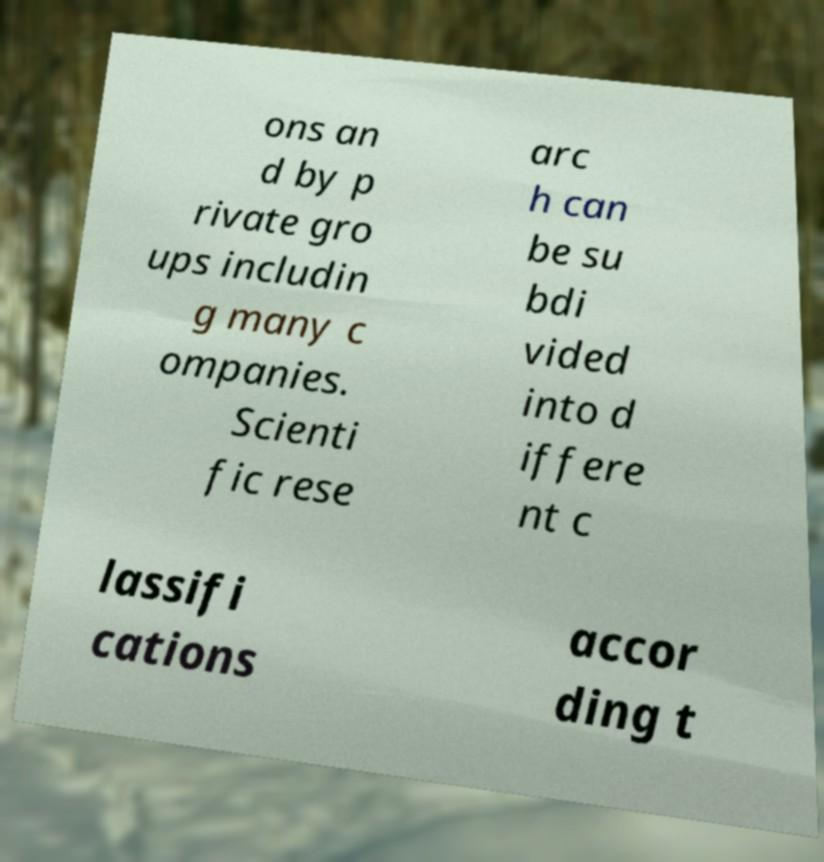Please identify and transcribe the text found in this image. ons an d by p rivate gro ups includin g many c ompanies. Scienti fic rese arc h can be su bdi vided into d iffere nt c lassifi cations accor ding t 